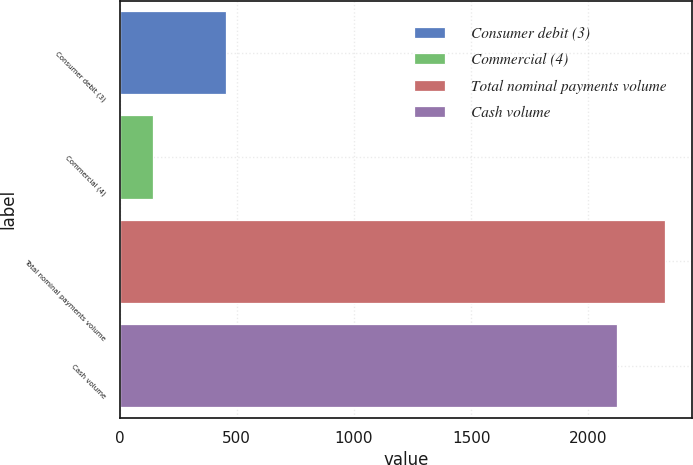Convert chart. <chart><loc_0><loc_0><loc_500><loc_500><bar_chart><fcel>Consumer debit (3)<fcel>Commercial (4)<fcel>Total nominal payments volume<fcel>Cash volume<nl><fcel>454<fcel>145<fcel>2327.3<fcel>2122<nl></chart> 